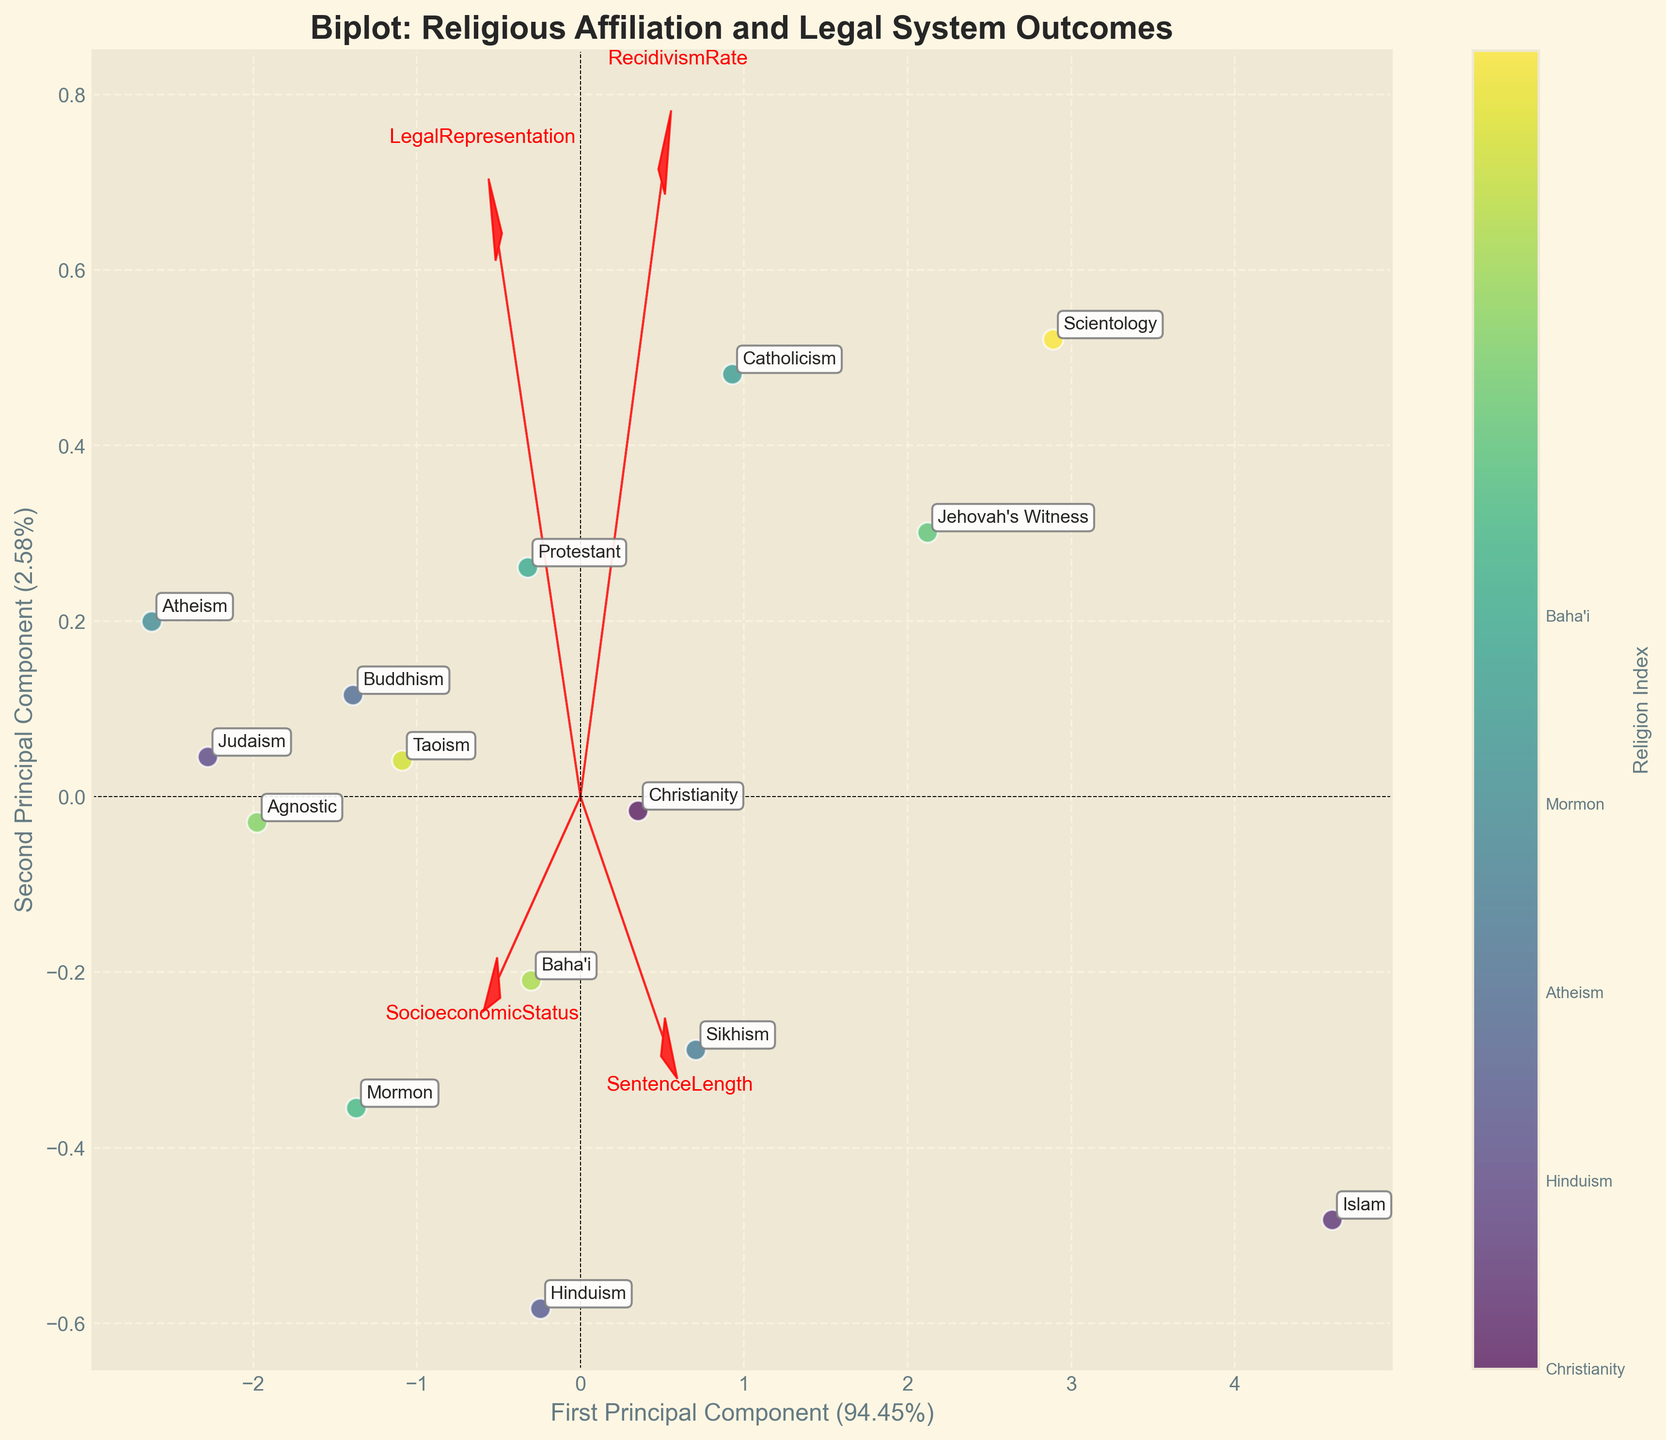what does the plot title say? The title is usually at the top of the plot, summarizing the content. It should describe the relationship being depicted.
Answer: Biplot: Religious Affiliation and Legal System Outcomes How many data points are displayed? Each point on the biplot corresponds to a religion, and each point has a label with the religion's name. Counting each labeled point provides the answer.
Answer: 15 Which religion has the highest value on the first principal component? The first principal component is on the x-axis. By locating the point farthest to the right, we can determine which religion has the highest value.
Answer: Scientology Which feature vector is closest to the second principal component axis? The second principal component is the y-axis. The feature vector closest to this axis can be determined by observing the direction of arrows and finding the one closest vertically.
Answer: RecidivismRate Does Hinduism have a higher component value on the first or second principal component? Hinduism’s position relative to the origin can be used to compare its values on the x and y axes.
Answer: First principal component How do the features LegalRepresentation and SocioeconomicStatus compare in terms of their vector length? The length of the vectors represents the importance of these features. Comparing the lengths visually will indicate which one is longer.
Answer: SocioeconomicStatus has a longer vector What is the range of the explained variance for the two principal components? The explained variance percentages are indicated on the axes. Observing these labels will provide the answer.
Answer: Around 40.7% and 25.7% Which religions are closely grouped together? By looking for clusters of points, we can identify which religions appear close to each other on the plot.
Answer: Buddhism, Taoism, and Hinduism What does the color gradient represent in the plot? The color gradient is usually indicated by the colorbar and it maps to a variable, in this case, the religion index.
Answer: Religion Index 